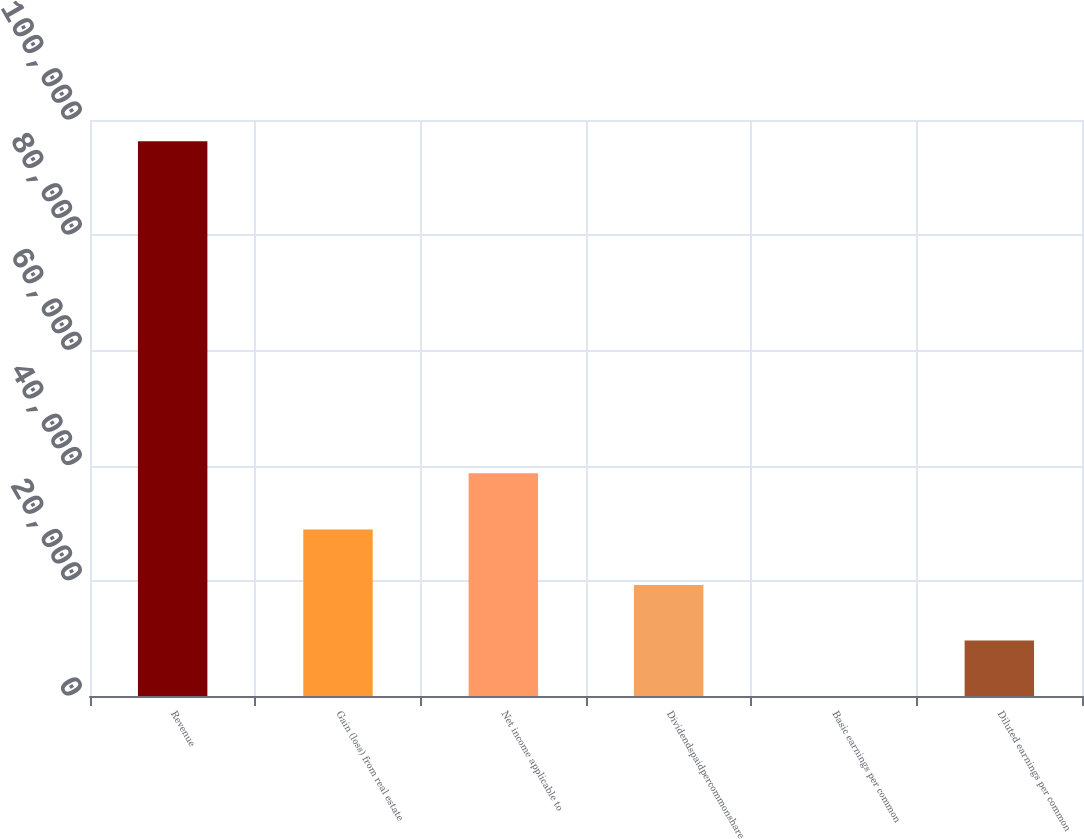<chart> <loc_0><loc_0><loc_500><loc_500><bar_chart><fcel>Revenue<fcel>Gain (loss) from real estate<fcel>Net income applicable to<fcel>Dividendspaidpercommonshare<fcel>Basic earnings per common<fcel>Diluted earnings per common<nl><fcel>96327<fcel>28898.3<fcel>38680<fcel>19265.7<fcel>0.31<fcel>9632.98<nl></chart> 